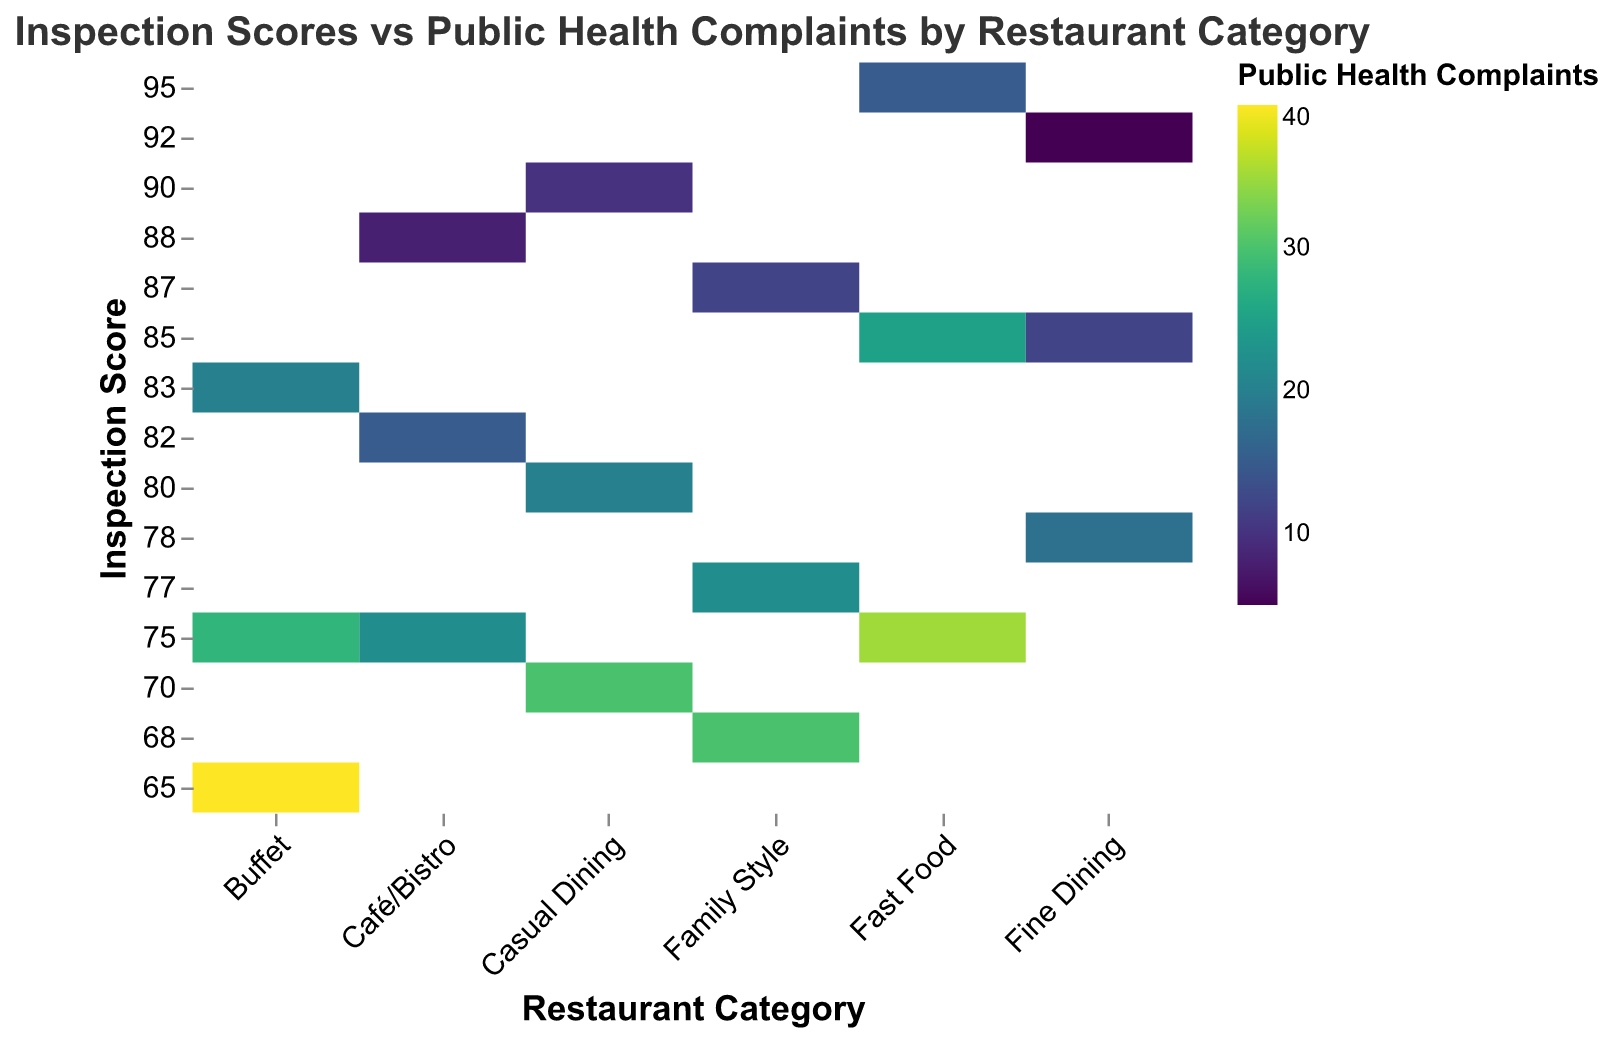What is the title of the heatmap? Look at the top of the heatmap where the title is usually located.
Answer: Inspection Scores vs Public Health Complaints by Restaurant Category Which restaurant category has the highest inspection score and the fewest public health complaints? Identify the category on the x-axis corresponding to the highest y-axis value (inspection score) and find the lowest color intensity (fewer complaints) within that category. The highest score is 95 for Fast Food with 15 complaints.
Answer: Fast Food How do Fast Food restaurants compare to Fine Dining restaurants in terms of public health complaints? Compare the color intensities for the corresponding inspection scores between Fast Food and Fine Dining. Fast Food has generally higher complaints for similar inspection scores.
Answer: Fast Food has more complaints What is the average number of public health complaints for Casual Dining restaurants with inspection scores of 80 and 70? Identify and sum the public health complaints for Casual Dining at inspection scores 80 and 70 (which are 20 and 30), then divide by 2. Calculation: (20 + 30) / 2 = 25
Answer: 25 How does the complaint level change for Buffet restaurants as the inspection score decreases from 83 to 65? Examine the color intensity progression in Buffet restaurants from 83 to 65 on the y-axis (darker color indicates more complaints). Complaints increase from 20 to 40.
Answer: Complaints increase Which restaurant category has the most variation in public health complaints across the different inspection scores? Assess the range of color intensities in each category along the y-axis. Family Style shows significant variation from 12 to 30 complaints.
Answer: Family Style Within the Fine Dining category, what is the range of public health complaints for inspection scores provided? Identify the highest and lowest number of complaints in the Fine Dining category. Complaints range from 5 to 18.
Answer: 5 to 18 How many public health complaints are there for a Café/Bistro with an inspection score of 75? Find the intersection of Café/Bistro on the x-axis and 75 on the y-axis and read the color intensity. The complaint number is 22.
Answer: 22 Compare the inspection scores between Casual Dining and Family Style when public health complaints are around 20. Identify data points where public health complaints are close to 20 and compare their inspection scores. Casual Dining has 80, Family Style has 77.
Answer: Casual Dining has higher inspection scores 